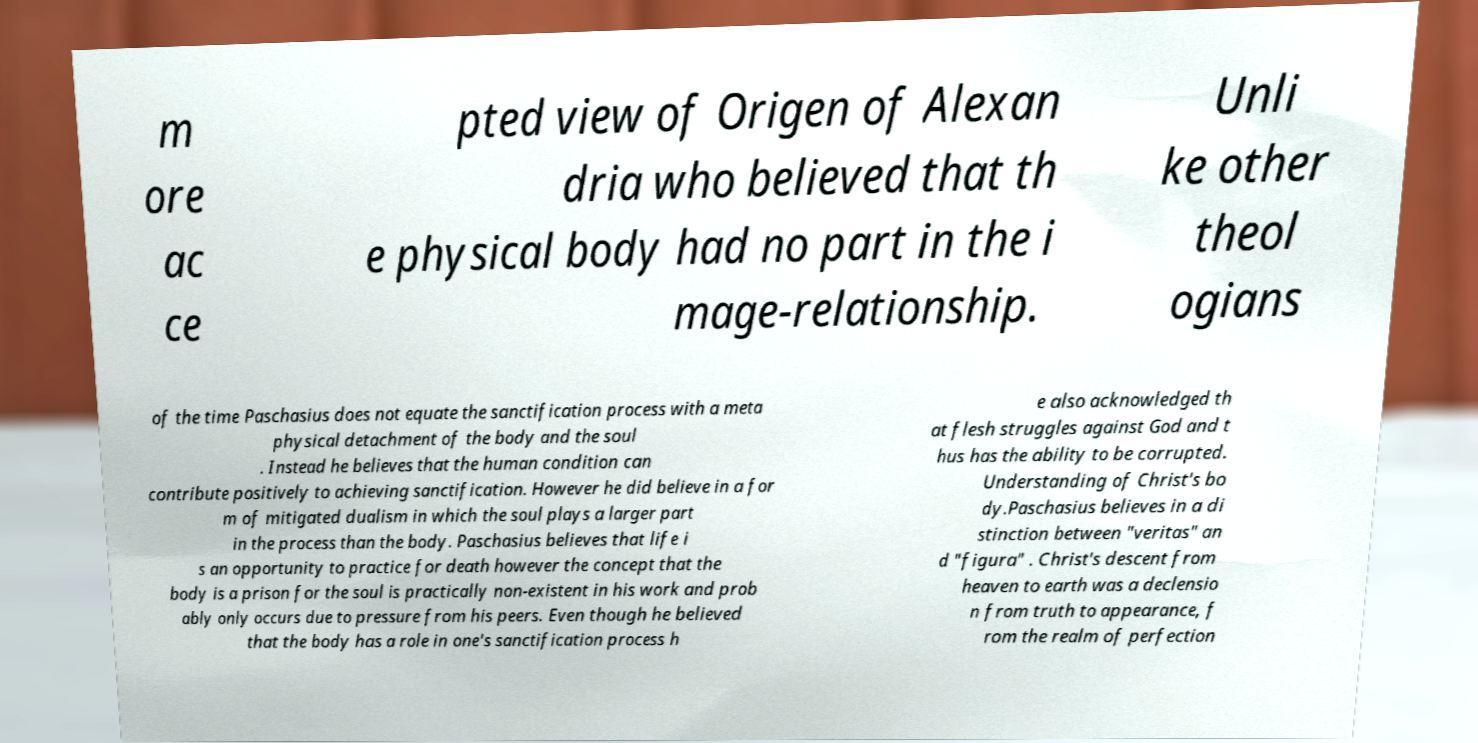There's text embedded in this image that I need extracted. Can you transcribe it verbatim? m ore ac ce pted view of Origen of Alexan dria who believed that th e physical body had no part in the i mage-relationship. Unli ke other theol ogians of the time Paschasius does not equate the sanctification process with a meta physical detachment of the body and the soul . Instead he believes that the human condition can contribute positively to achieving sanctification. However he did believe in a for m of mitigated dualism in which the soul plays a larger part in the process than the body. Paschasius believes that life i s an opportunity to practice for death however the concept that the body is a prison for the soul is practically non-existent in his work and prob ably only occurs due to pressure from his peers. Even though he believed that the body has a role in one's sanctification process h e also acknowledged th at flesh struggles against God and t hus has the ability to be corrupted. Understanding of Christ's bo dy.Paschasius believes in a di stinction between "veritas" an d "figura" . Christ's descent from heaven to earth was a declensio n from truth to appearance, f rom the realm of perfection 